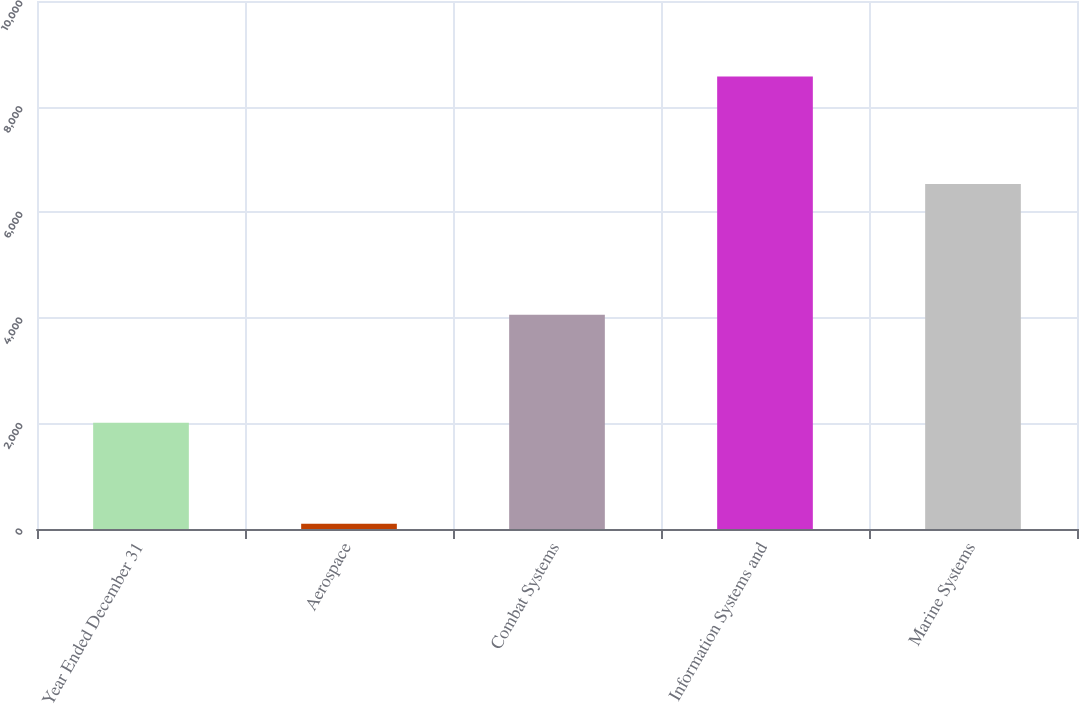Convert chart to OTSL. <chart><loc_0><loc_0><loc_500><loc_500><bar_chart><fcel>Year Ended December 31<fcel>Aerospace<fcel>Combat Systems<fcel>Information Systems and<fcel>Marine Systems<nl><fcel>2013<fcel>98<fcel>4057<fcel>8572<fcel>6536<nl></chart> 